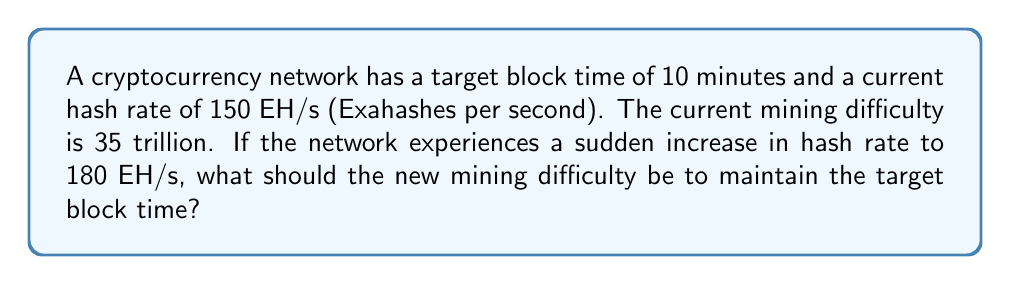Teach me how to tackle this problem. Let's approach this step-by-step:

1) First, we need to understand the relationship between hash rate, difficulty, and block time:

   $$ \text{Block Time} = \frac{\text{Difficulty} \times 2^{32}}{\text{Hash Rate}} $$

2) We know that the current state satisfies this equation:

   $$ 10 \text{ minutes} = \frac{35 \times 10^{12} \times 2^{32}}{150 \times 10^{18}} $$

3) For the new hash rate, we want to maintain the same block time. Let's call the new difficulty $D$:

   $$ 10 \text{ minutes} = \frac{D \times 2^{32}}{180 \times 10^{18}} $$

4) We can set up a proportion based on these equations:

   $$ \frac{35 \times 10^{12}}{150 \times 10^{18}} = \frac{D}{180 \times 10^{18}} $$

5) Cross multiply:

   $$ 35 \times 10^{12} \times 180 \times 10^{18} = 150 \times 10^{18} \times D $$

6) Simplify:

   $$ 6300 \times 10^{30} = 150 \times 10^{18} \times D $$

7) Solve for $D$:

   $$ D = \frac{6300 \times 10^{30}}{150 \times 10^{18}} = 42 \times 10^{12} $$

Thus, the new mining difficulty should be 42 trillion.
Answer: 42 trillion 